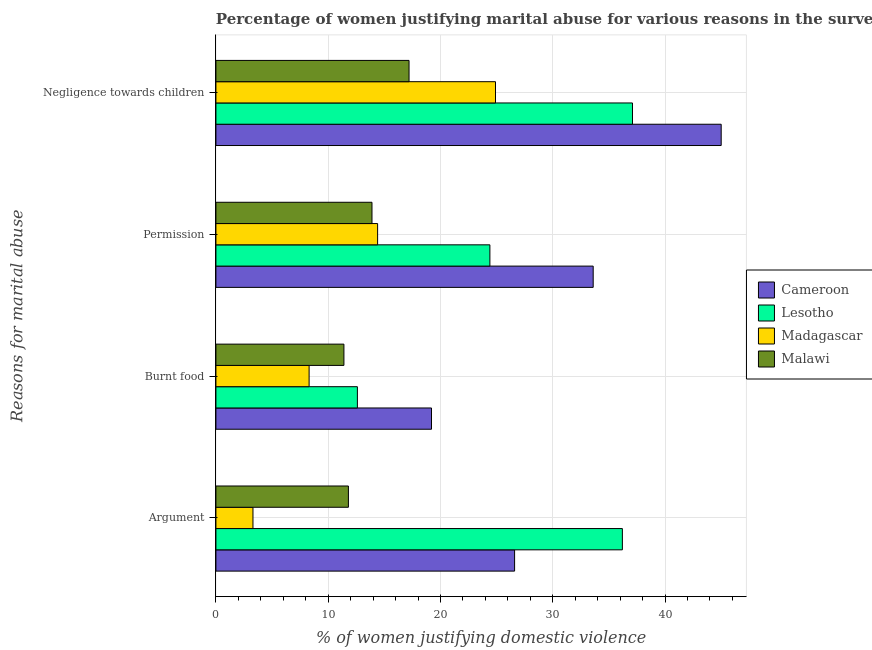Are the number of bars per tick equal to the number of legend labels?
Give a very brief answer. Yes. How many bars are there on the 3rd tick from the top?
Your response must be concise. 4. How many bars are there on the 2nd tick from the bottom?
Provide a short and direct response. 4. What is the label of the 3rd group of bars from the top?
Provide a succinct answer. Burnt food. What is the percentage of women justifying abuse for going without permission in Lesotho?
Ensure brevity in your answer.  24.4. Across all countries, what is the maximum percentage of women justifying abuse for going without permission?
Your response must be concise. 33.6. Across all countries, what is the minimum percentage of women justifying abuse for burning food?
Your response must be concise. 8.3. In which country was the percentage of women justifying abuse for burning food maximum?
Provide a succinct answer. Cameroon. In which country was the percentage of women justifying abuse in the case of an argument minimum?
Your answer should be compact. Madagascar. What is the total percentage of women justifying abuse for going without permission in the graph?
Provide a succinct answer. 86.3. What is the difference between the percentage of women justifying abuse in the case of an argument in Lesotho and the percentage of women justifying abuse for going without permission in Malawi?
Give a very brief answer. 22.3. What is the average percentage of women justifying abuse in the case of an argument per country?
Make the answer very short. 19.48. What is the difference between the percentage of women justifying abuse for burning food and percentage of women justifying abuse in the case of an argument in Lesotho?
Give a very brief answer. -23.6. In how many countries, is the percentage of women justifying abuse in the case of an argument greater than 30 %?
Provide a short and direct response. 1. What is the ratio of the percentage of women justifying abuse for burning food in Malawi to that in Lesotho?
Make the answer very short. 0.9. What is the difference between the highest and the second highest percentage of women justifying abuse for burning food?
Your answer should be compact. 6.6. What is the difference between the highest and the lowest percentage of women justifying abuse for going without permission?
Your answer should be compact. 19.7. What does the 2nd bar from the top in Negligence towards children represents?
Give a very brief answer. Madagascar. What does the 4th bar from the bottom in Argument represents?
Keep it short and to the point. Malawi. How many bars are there?
Provide a succinct answer. 16. Are all the bars in the graph horizontal?
Your response must be concise. Yes. Does the graph contain any zero values?
Offer a very short reply. No. How many legend labels are there?
Your answer should be very brief. 4. How are the legend labels stacked?
Keep it short and to the point. Vertical. What is the title of the graph?
Give a very brief answer. Percentage of women justifying marital abuse for various reasons in the survey of 2004. What is the label or title of the X-axis?
Offer a very short reply. % of women justifying domestic violence. What is the label or title of the Y-axis?
Offer a terse response. Reasons for marital abuse. What is the % of women justifying domestic violence of Cameroon in Argument?
Your answer should be very brief. 26.6. What is the % of women justifying domestic violence of Lesotho in Argument?
Make the answer very short. 36.2. What is the % of women justifying domestic violence in Madagascar in Argument?
Provide a short and direct response. 3.3. What is the % of women justifying domestic violence of Malawi in Argument?
Your answer should be compact. 11.8. What is the % of women justifying domestic violence in Lesotho in Burnt food?
Make the answer very short. 12.6. What is the % of women justifying domestic violence in Madagascar in Burnt food?
Give a very brief answer. 8.3. What is the % of women justifying domestic violence in Cameroon in Permission?
Provide a short and direct response. 33.6. What is the % of women justifying domestic violence in Lesotho in Permission?
Offer a terse response. 24.4. What is the % of women justifying domestic violence of Malawi in Permission?
Provide a succinct answer. 13.9. What is the % of women justifying domestic violence of Cameroon in Negligence towards children?
Offer a terse response. 45. What is the % of women justifying domestic violence in Lesotho in Negligence towards children?
Provide a succinct answer. 37.1. What is the % of women justifying domestic violence of Madagascar in Negligence towards children?
Offer a terse response. 24.9. Across all Reasons for marital abuse, what is the maximum % of women justifying domestic violence in Lesotho?
Ensure brevity in your answer.  37.1. Across all Reasons for marital abuse, what is the maximum % of women justifying domestic violence of Madagascar?
Ensure brevity in your answer.  24.9. Across all Reasons for marital abuse, what is the minimum % of women justifying domestic violence in Lesotho?
Your answer should be compact. 12.6. What is the total % of women justifying domestic violence in Cameroon in the graph?
Ensure brevity in your answer.  124.4. What is the total % of women justifying domestic violence of Lesotho in the graph?
Provide a succinct answer. 110.3. What is the total % of women justifying domestic violence of Madagascar in the graph?
Ensure brevity in your answer.  50.9. What is the total % of women justifying domestic violence in Malawi in the graph?
Make the answer very short. 54.3. What is the difference between the % of women justifying domestic violence in Cameroon in Argument and that in Burnt food?
Provide a succinct answer. 7.4. What is the difference between the % of women justifying domestic violence in Lesotho in Argument and that in Burnt food?
Make the answer very short. 23.6. What is the difference between the % of women justifying domestic violence of Madagascar in Argument and that in Burnt food?
Keep it short and to the point. -5. What is the difference between the % of women justifying domestic violence in Lesotho in Argument and that in Permission?
Ensure brevity in your answer.  11.8. What is the difference between the % of women justifying domestic violence in Cameroon in Argument and that in Negligence towards children?
Your answer should be compact. -18.4. What is the difference between the % of women justifying domestic violence of Madagascar in Argument and that in Negligence towards children?
Your answer should be compact. -21.6. What is the difference between the % of women justifying domestic violence in Cameroon in Burnt food and that in Permission?
Make the answer very short. -14.4. What is the difference between the % of women justifying domestic violence of Malawi in Burnt food and that in Permission?
Keep it short and to the point. -2.5. What is the difference between the % of women justifying domestic violence of Cameroon in Burnt food and that in Negligence towards children?
Make the answer very short. -25.8. What is the difference between the % of women justifying domestic violence of Lesotho in Burnt food and that in Negligence towards children?
Your answer should be compact. -24.5. What is the difference between the % of women justifying domestic violence in Madagascar in Burnt food and that in Negligence towards children?
Your answer should be compact. -16.6. What is the difference between the % of women justifying domestic violence in Lesotho in Permission and that in Negligence towards children?
Ensure brevity in your answer.  -12.7. What is the difference between the % of women justifying domestic violence of Cameroon in Argument and the % of women justifying domestic violence of Madagascar in Burnt food?
Your response must be concise. 18.3. What is the difference between the % of women justifying domestic violence of Cameroon in Argument and the % of women justifying domestic violence of Malawi in Burnt food?
Offer a very short reply. 15.2. What is the difference between the % of women justifying domestic violence of Lesotho in Argument and the % of women justifying domestic violence of Madagascar in Burnt food?
Provide a short and direct response. 27.9. What is the difference between the % of women justifying domestic violence of Lesotho in Argument and the % of women justifying domestic violence of Malawi in Burnt food?
Provide a short and direct response. 24.8. What is the difference between the % of women justifying domestic violence of Madagascar in Argument and the % of women justifying domestic violence of Malawi in Burnt food?
Ensure brevity in your answer.  -8.1. What is the difference between the % of women justifying domestic violence of Lesotho in Argument and the % of women justifying domestic violence of Madagascar in Permission?
Provide a short and direct response. 21.8. What is the difference between the % of women justifying domestic violence in Lesotho in Argument and the % of women justifying domestic violence in Malawi in Permission?
Offer a terse response. 22.3. What is the difference between the % of women justifying domestic violence of Madagascar in Argument and the % of women justifying domestic violence of Malawi in Permission?
Ensure brevity in your answer.  -10.6. What is the difference between the % of women justifying domestic violence in Cameroon in Argument and the % of women justifying domestic violence in Malawi in Negligence towards children?
Provide a succinct answer. 9.4. What is the difference between the % of women justifying domestic violence in Lesotho in Argument and the % of women justifying domestic violence in Madagascar in Negligence towards children?
Ensure brevity in your answer.  11.3. What is the difference between the % of women justifying domestic violence in Lesotho in Argument and the % of women justifying domestic violence in Malawi in Negligence towards children?
Your answer should be very brief. 19. What is the difference between the % of women justifying domestic violence of Madagascar in Argument and the % of women justifying domestic violence of Malawi in Negligence towards children?
Provide a short and direct response. -13.9. What is the difference between the % of women justifying domestic violence in Cameroon in Burnt food and the % of women justifying domestic violence in Madagascar in Permission?
Ensure brevity in your answer.  4.8. What is the difference between the % of women justifying domestic violence of Cameroon in Burnt food and the % of women justifying domestic violence of Malawi in Permission?
Ensure brevity in your answer.  5.3. What is the difference between the % of women justifying domestic violence in Lesotho in Burnt food and the % of women justifying domestic violence in Madagascar in Permission?
Offer a terse response. -1.8. What is the difference between the % of women justifying domestic violence in Cameroon in Burnt food and the % of women justifying domestic violence in Lesotho in Negligence towards children?
Offer a terse response. -17.9. What is the difference between the % of women justifying domestic violence in Lesotho in Burnt food and the % of women justifying domestic violence in Malawi in Negligence towards children?
Your answer should be very brief. -4.6. What is the difference between the % of women justifying domestic violence in Madagascar in Burnt food and the % of women justifying domestic violence in Malawi in Negligence towards children?
Ensure brevity in your answer.  -8.9. What is the difference between the % of women justifying domestic violence of Lesotho in Permission and the % of women justifying domestic violence of Madagascar in Negligence towards children?
Offer a very short reply. -0.5. What is the difference between the % of women justifying domestic violence of Lesotho in Permission and the % of women justifying domestic violence of Malawi in Negligence towards children?
Give a very brief answer. 7.2. What is the difference between the % of women justifying domestic violence of Madagascar in Permission and the % of women justifying domestic violence of Malawi in Negligence towards children?
Provide a short and direct response. -2.8. What is the average % of women justifying domestic violence of Cameroon per Reasons for marital abuse?
Your response must be concise. 31.1. What is the average % of women justifying domestic violence of Lesotho per Reasons for marital abuse?
Offer a terse response. 27.57. What is the average % of women justifying domestic violence of Madagascar per Reasons for marital abuse?
Give a very brief answer. 12.72. What is the average % of women justifying domestic violence in Malawi per Reasons for marital abuse?
Keep it short and to the point. 13.57. What is the difference between the % of women justifying domestic violence in Cameroon and % of women justifying domestic violence in Madagascar in Argument?
Offer a terse response. 23.3. What is the difference between the % of women justifying domestic violence in Cameroon and % of women justifying domestic violence in Malawi in Argument?
Keep it short and to the point. 14.8. What is the difference between the % of women justifying domestic violence in Lesotho and % of women justifying domestic violence in Madagascar in Argument?
Make the answer very short. 32.9. What is the difference between the % of women justifying domestic violence in Lesotho and % of women justifying domestic violence in Malawi in Argument?
Make the answer very short. 24.4. What is the difference between the % of women justifying domestic violence of Madagascar and % of women justifying domestic violence of Malawi in Argument?
Your answer should be very brief. -8.5. What is the difference between the % of women justifying domestic violence of Cameroon and % of women justifying domestic violence of Lesotho in Burnt food?
Your answer should be compact. 6.6. What is the difference between the % of women justifying domestic violence of Cameroon and % of women justifying domestic violence of Madagascar in Burnt food?
Make the answer very short. 10.9. What is the difference between the % of women justifying domestic violence of Cameroon and % of women justifying domestic violence of Malawi in Burnt food?
Offer a terse response. 7.8. What is the difference between the % of women justifying domestic violence in Lesotho and % of women justifying domestic violence in Malawi in Burnt food?
Ensure brevity in your answer.  1.2. What is the difference between the % of women justifying domestic violence in Madagascar and % of women justifying domestic violence in Malawi in Burnt food?
Offer a terse response. -3.1. What is the difference between the % of women justifying domestic violence of Cameroon and % of women justifying domestic violence of Lesotho in Permission?
Make the answer very short. 9.2. What is the difference between the % of women justifying domestic violence in Lesotho and % of women justifying domestic violence in Madagascar in Permission?
Keep it short and to the point. 10. What is the difference between the % of women justifying domestic violence in Madagascar and % of women justifying domestic violence in Malawi in Permission?
Your response must be concise. 0.5. What is the difference between the % of women justifying domestic violence of Cameroon and % of women justifying domestic violence of Lesotho in Negligence towards children?
Your response must be concise. 7.9. What is the difference between the % of women justifying domestic violence of Cameroon and % of women justifying domestic violence of Madagascar in Negligence towards children?
Offer a terse response. 20.1. What is the difference between the % of women justifying domestic violence of Cameroon and % of women justifying domestic violence of Malawi in Negligence towards children?
Keep it short and to the point. 27.8. What is the difference between the % of women justifying domestic violence of Lesotho and % of women justifying domestic violence of Madagascar in Negligence towards children?
Provide a short and direct response. 12.2. What is the difference between the % of women justifying domestic violence of Madagascar and % of women justifying domestic violence of Malawi in Negligence towards children?
Offer a terse response. 7.7. What is the ratio of the % of women justifying domestic violence of Cameroon in Argument to that in Burnt food?
Provide a succinct answer. 1.39. What is the ratio of the % of women justifying domestic violence in Lesotho in Argument to that in Burnt food?
Give a very brief answer. 2.87. What is the ratio of the % of women justifying domestic violence in Madagascar in Argument to that in Burnt food?
Keep it short and to the point. 0.4. What is the ratio of the % of women justifying domestic violence of Malawi in Argument to that in Burnt food?
Make the answer very short. 1.04. What is the ratio of the % of women justifying domestic violence of Cameroon in Argument to that in Permission?
Make the answer very short. 0.79. What is the ratio of the % of women justifying domestic violence in Lesotho in Argument to that in Permission?
Your answer should be compact. 1.48. What is the ratio of the % of women justifying domestic violence of Madagascar in Argument to that in Permission?
Provide a short and direct response. 0.23. What is the ratio of the % of women justifying domestic violence in Malawi in Argument to that in Permission?
Give a very brief answer. 0.85. What is the ratio of the % of women justifying domestic violence of Cameroon in Argument to that in Negligence towards children?
Your response must be concise. 0.59. What is the ratio of the % of women justifying domestic violence in Lesotho in Argument to that in Negligence towards children?
Provide a succinct answer. 0.98. What is the ratio of the % of women justifying domestic violence of Madagascar in Argument to that in Negligence towards children?
Provide a succinct answer. 0.13. What is the ratio of the % of women justifying domestic violence of Malawi in Argument to that in Negligence towards children?
Ensure brevity in your answer.  0.69. What is the ratio of the % of women justifying domestic violence of Lesotho in Burnt food to that in Permission?
Make the answer very short. 0.52. What is the ratio of the % of women justifying domestic violence of Madagascar in Burnt food to that in Permission?
Provide a short and direct response. 0.58. What is the ratio of the % of women justifying domestic violence in Malawi in Burnt food to that in Permission?
Provide a short and direct response. 0.82. What is the ratio of the % of women justifying domestic violence in Cameroon in Burnt food to that in Negligence towards children?
Your answer should be compact. 0.43. What is the ratio of the % of women justifying domestic violence of Lesotho in Burnt food to that in Negligence towards children?
Your answer should be compact. 0.34. What is the ratio of the % of women justifying domestic violence of Madagascar in Burnt food to that in Negligence towards children?
Your answer should be compact. 0.33. What is the ratio of the % of women justifying domestic violence in Malawi in Burnt food to that in Negligence towards children?
Your answer should be compact. 0.66. What is the ratio of the % of women justifying domestic violence of Cameroon in Permission to that in Negligence towards children?
Your answer should be very brief. 0.75. What is the ratio of the % of women justifying domestic violence of Lesotho in Permission to that in Negligence towards children?
Make the answer very short. 0.66. What is the ratio of the % of women justifying domestic violence of Madagascar in Permission to that in Negligence towards children?
Make the answer very short. 0.58. What is the ratio of the % of women justifying domestic violence in Malawi in Permission to that in Negligence towards children?
Your answer should be compact. 0.81. What is the difference between the highest and the second highest % of women justifying domestic violence of Lesotho?
Ensure brevity in your answer.  0.9. What is the difference between the highest and the lowest % of women justifying domestic violence of Cameroon?
Make the answer very short. 25.8. What is the difference between the highest and the lowest % of women justifying domestic violence of Madagascar?
Make the answer very short. 21.6. What is the difference between the highest and the lowest % of women justifying domestic violence in Malawi?
Your answer should be compact. 5.8. 